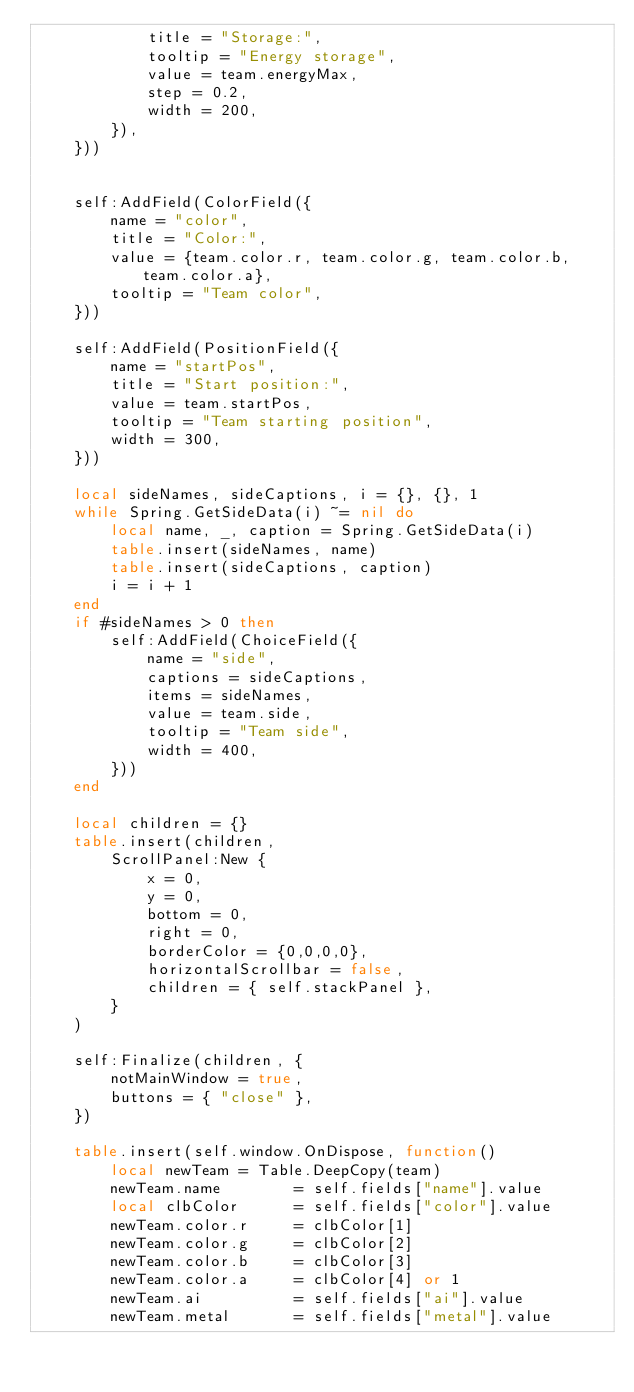Convert code to text. <code><loc_0><loc_0><loc_500><loc_500><_Lua_>            title = "Storage:",
            tooltip = "Energy storage",
            value = team.energyMax,
            step = 0.2,
            width = 200,
        }),
    }))


    self:AddField(ColorField({
        name = "color",
        title = "Color:",
        value = {team.color.r, team.color.g, team.color.b, team.color.a},
        tooltip = "Team color",
    }))

    self:AddField(PositionField({
        name = "startPos",
        title = "Start position:",
        value = team.startPos,
        tooltip = "Team starting position",
        width = 300,
    }))

    local sideNames, sideCaptions, i = {}, {}, 1
    while Spring.GetSideData(i) ~= nil do
        local name, _, caption = Spring.GetSideData(i)
        table.insert(sideNames, name)
        table.insert(sideCaptions, caption)
        i = i + 1
    end
    if #sideNames > 0 then
        self:AddField(ChoiceField({
            name = "side",
            captions = sideCaptions,
            items = sideNames,
            value = team.side,
            tooltip = "Team side",
            width = 400,
        }))
    end

    local children = {}
    table.insert(children,
        ScrollPanel:New {
            x = 0,
            y = 0,
            bottom = 0,
            right = 0,
            borderColor = {0,0,0,0},
            horizontalScrollbar = false,
            children = { self.stackPanel },
        }
    )

    self:Finalize(children, {
        notMainWindow = true,
        buttons = { "close" },
    })

    table.insert(self.window.OnDispose, function()
        local newTeam = Table.DeepCopy(team)
        newTeam.name        = self.fields["name"].value
        local clbColor      = self.fields["color"].value
        newTeam.color.r     = clbColor[1]
        newTeam.color.g     = clbColor[2]
        newTeam.color.b     = clbColor[3]
        newTeam.color.a     = clbColor[4] or 1
        newTeam.ai          = self.fields["ai"].value
        newTeam.metal       = self.fields["metal"].value</code> 